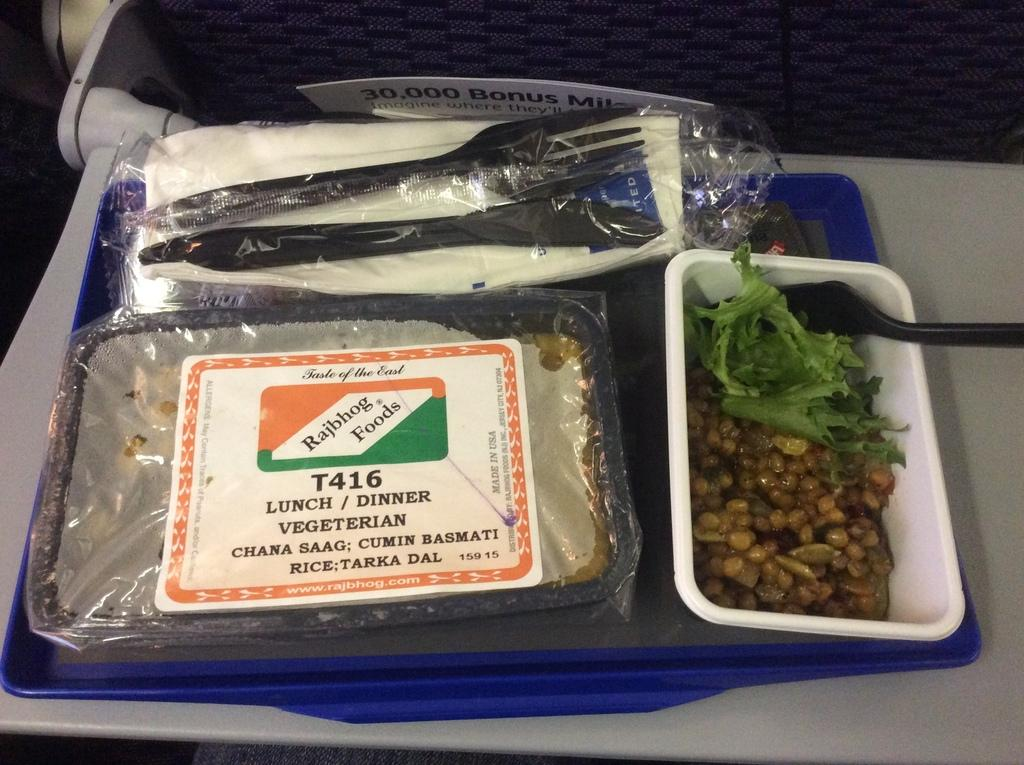What type of items are contained within the boxes in the image? There are boxes with food in the image. What utensils are visible in the image? There are forks visible in the image. What is the large, flat object in the image? There is a board in the image. What color is the tray that holds the objects? The tray is on a blue color tray. What is the surface beneath the tray? The tray is on a white color surface. What type of addition can be seen in the image? There is no addition present in the image; it features boxes with food, forks, a board, and a tray on a white surface. Is there an airplane visible in the image? No, there is no airplane present in the image. 